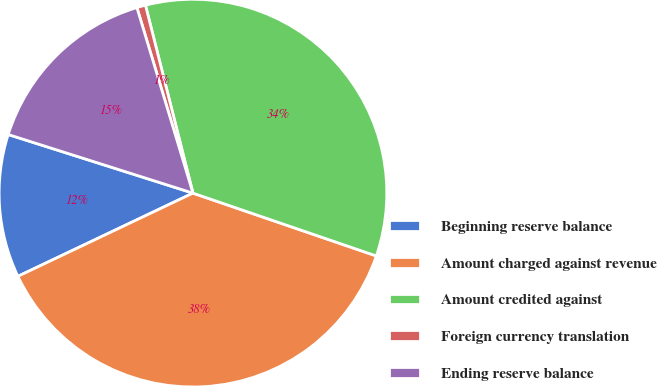<chart> <loc_0><loc_0><loc_500><loc_500><pie_chart><fcel>Beginning reserve balance<fcel>Amount charged against revenue<fcel>Amount credited against<fcel>Foreign currency translation<fcel>Ending reserve balance<nl><fcel>11.95%<fcel>37.68%<fcel>34.19%<fcel>0.73%<fcel>15.44%<nl></chart> 